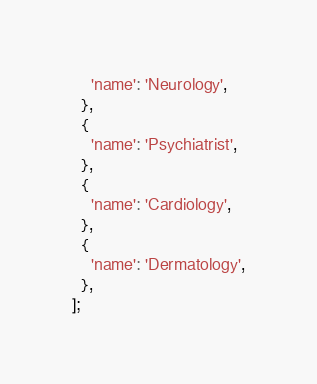<code> <loc_0><loc_0><loc_500><loc_500><_Dart_>    'name': 'Neurology',
  },
  {
    'name': 'Psychiatrist',
  },
  {
    'name': 'Cardiology',
  },
  {
    'name': 'Dermatology',
  },
];
</code> 